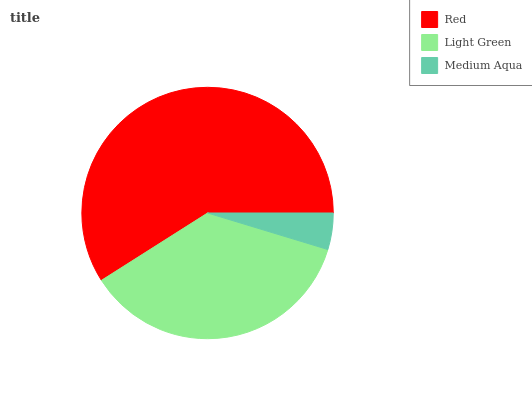Is Medium Aqua the minimum?
Answer yes or no. Yes. Is Red the maximum?
Answer yes or no. Yes. Is Light Green the minimum?
Answer yes or no. No. Is Light Green the maximum?
Answer yes or no. No. Is Red greater than Light Green?
Answer yes or no. Yes. Is Light Green less than Red?
Answer yes or no. Yes. Is Light Green greater than Red?
Answer yes or no. No. Is Red less than Light Green?
Answer yes or no. No. Is Light Green the high median?
Answer yes or no. Yes. Is Light Green the low median?
Answer yes or no. Yes. Is Medium Aqua the high median?
Answer yes or no. No. Is Medium Aqua the low median?
Answer yes or no. No. 